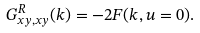<formula> <loc_0><loc_0><loc_500><loc_500>G ^ { R } _ { x y , x y } ( k ) = - 2 F ( k , u = 0 ) .</formula> 